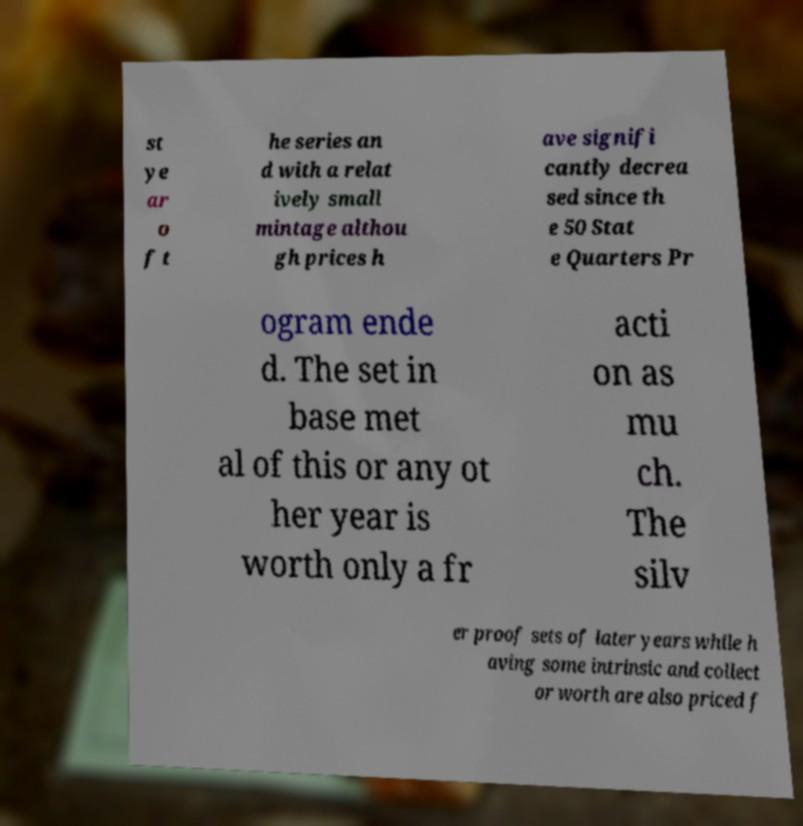Can you read and provide the text displayed in the image?This photo seems to have some interesting text. Can you extract and type it out for me? st ye ar o f t he series an d with a relat ively small mintage althou gh prices h ave signifi cantly decrea sed since th e 50 Stat e Quarters Pr ogram ende d. The set in base met al of this or any ot her year is worth only a fr acti on as mu ch. The silv er proof sets of later years while h aving some intrinsic and collect or worth are also priced f 